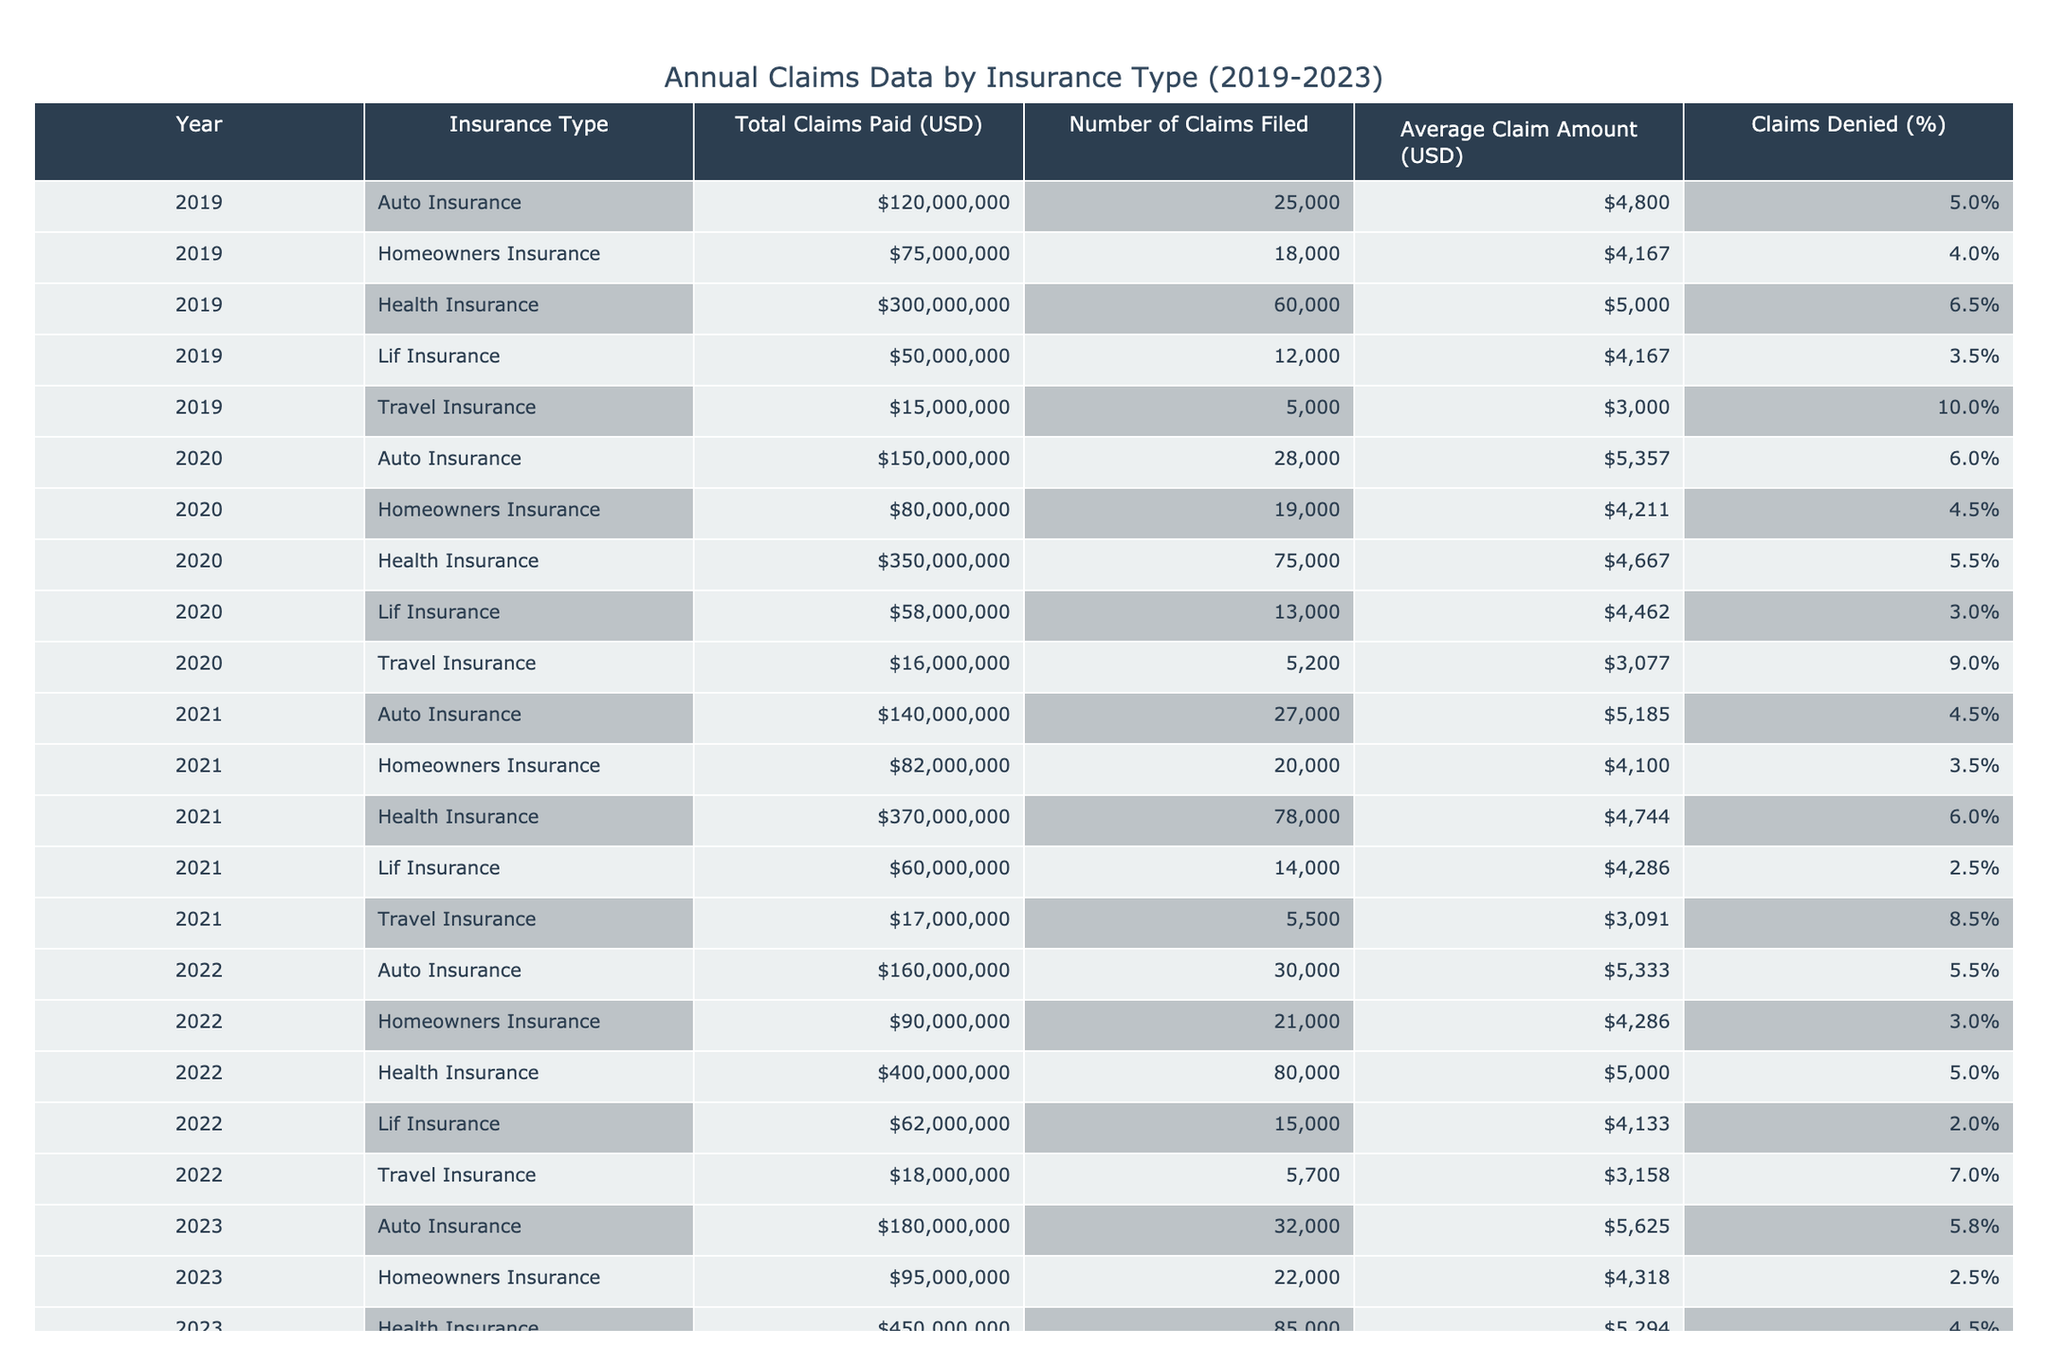What was the total claims paid for Health Insurance in 2020? The table indicates that in the year 2020, the total claims paid for Health Insurance amount to 350000000 USD. This value can be found directly in the row corresponding to Health Insurance for the year 2020.
Answer: 350000000 USD Which insurance type had the highest average claim amount in 2022? For the year 2022, the average claim amounts for each insurance type are as follows: Auto Insurance 5333 USD, Homeowners Insurance 4286 USD, Health Insurance 5000 USD, Life Insurance 4133 USD, and Travel Insurance 3158 USD. Auto Insurance has the highest average claim amount of 5333 USD.
Answer: Auto Insurance Did the percentage of claims denied for Homeowners Insurance decrease from 2019 to 2023? In 2019, the percentage of claims denied for Homeowners Insurance was 4.0%, and in 2023 it decreased to 2.5%. Since 2.5% is less than 4.0%, the percentage of claims denied did indeed decrease over this period.
Answer: Yes What is the total number of claims filed for Auto Insurance from 2019 to 2023? The number of claims filed for Auto Insurance over the years are: 25000 (2019) + 28000 (2020) + 27000 (2021) + 30000 (2022) + 32000 (2023). Summing these gives a total of 25000 + 28000 + 27000 + 30000 + 32000 = 142000 claims.
Answer: 142000 claims What was the increase in total claims paid for Travel Insurance from 2019 to 2023? Total claims paid for Travel Insurance are 15000000 USD in 2019 and 19000000 USD in 2023. The increase can be calculated as 19000000 - 15000000 = 4000000 USD.
Answer: 4000000 USD How does the average claim amount for Life Insurance in 2021 compare to that of 2023? The average claim amount for Life Insurance in 2021 is 4286 USD, while in 2023 it is 4063 USD. Since 4063 USD is less than 4286 USD, the average claim amount for Life Insurance decreased.
Answer: Decreased What percentage of claims for Health Insurance were denied in 2021? The table indicates that for Health Insurance in 2021, the percentage of claims denied was 6.0%. This value can be directly obtained from the corresponding row for Health Insurance in 2021.
Answer: 6.0% Which insurance type consistently had the lowest average claim amount between 2019 and 2023? Reviewing the average claim amounts across the years, Travel Insurance has the lowest average amounts each year: 3000 USD (2019), 3077 USD (2020), 3091 USD (2021), 3158 USD (2022), and 3167 USD (2023). Thus, Travel Insurance consistently had the lowest average claim amount over the five years.
Answer: Travel Insurance Was the total claims paid for Homeowners Insurance higher in 2021 than in 2022? The total claims paid for Homeowners Insurance were 82000000 USD in 2021 and 90000000 USD in 2022. Since 90000000 USD is greater than 82000000 USD, the claims paid were indeed higher in 2022.
Answer: No 